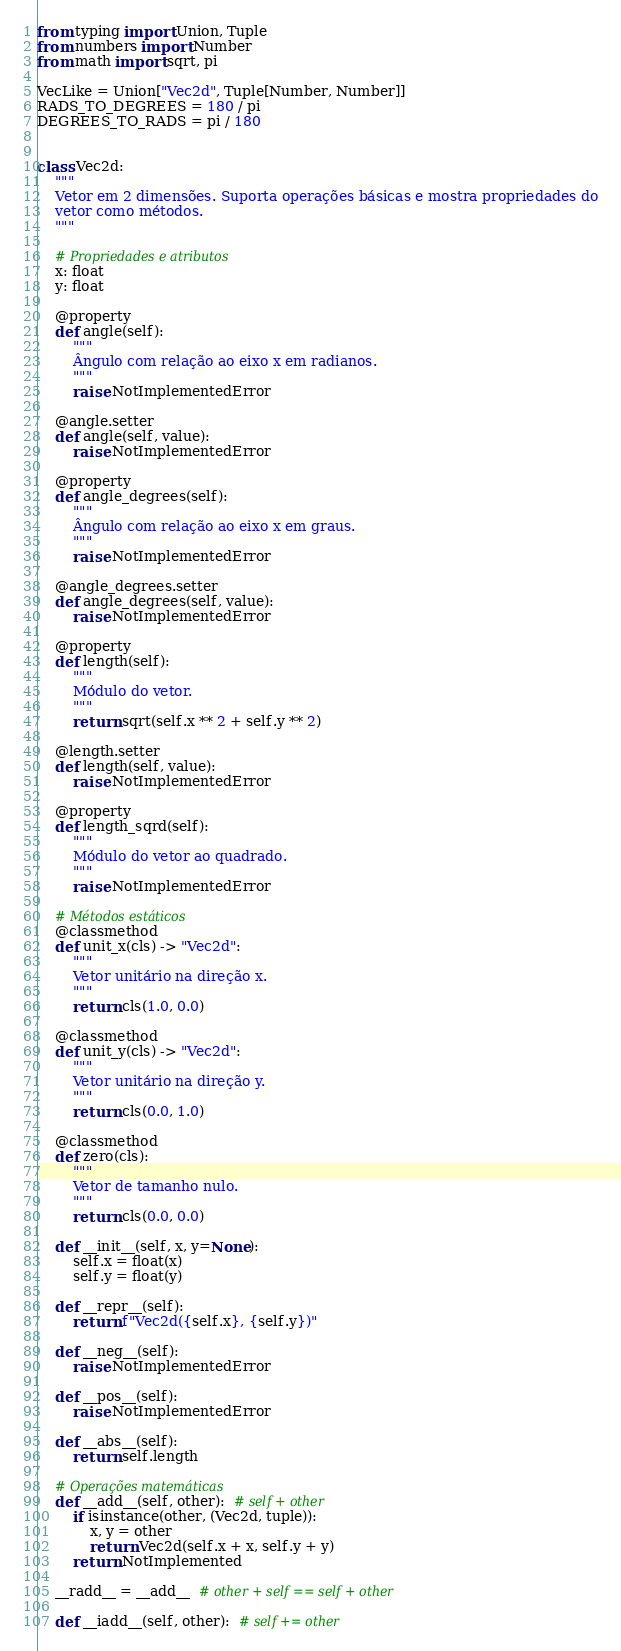<code> <loc_0><loc_0><loc_500><loc_500><_Python_>from typing import Union, Tuple
from numbers import Number
from math import sqrt, pi

VecLike = Union["Vec2d", Tuple[Number, Number]]
RADS_TO_DEGREES = 180 / pi
DEGREES_TO_RADS = pi / 180


class Vec2d:
    """
    Vetor em 2 dimensões. Suporta operações básicas e mostra propriedades do
    vetor como métodos.
    """

    # Propriedades e atributos
    x: float
    y: float

    @property
    def angle(self):
        """
        Ângulo com relação ao eixo x em radianos.
        """
        raise NotImplementedError

    @angle.setter
    def angle(self, value):
        raise NotImplementedError

    @property
    def angle_degrees(self):
        """
        Ângulo com relação ao eixo x em graus.
        """
        raise NotImplementedError

    @angle_degrees.setter
    def angle_degrees(self, value):
        raise NotImplementedError

    @property
    def length(self):
        """
        Módulo do vetor.
        """
        return sqrt(self.x ** 2 + self.y ** 2)

    @length.setter
    def length(self, value):
        raise NotImplementedError

    @property
    def length_sqrd(self):
        """
        Módulo do vetor ao quadrado.
        """
        raise NotImplementedError

    # Métodos estáticos
    @classmethod
    def unit_x(cls) -> "Vec2d":
        """
        Vetor unitário na direção x.
        """
        return cls(1.0, 0.0)

    @classmethod
    def unit_y(cls) -> "Vec2d":
        """
        Vetor unitário na direção y.
        """
        return cls(0.0, 1.0)

    @classmethod
    def zero(cls):
        """
        Vetor de tamanho nulo.
        """
        return cls(0.0, 0.0)

    def __init__(self, x, y=None):
        self.x = float(x)
        self.y = float(y)

    def __repr__(self):
        return f"Vec2d({self.x}, {self.y})"

    def __neg__(self):
        raise NotImplementedError

    def __pos__(self):
        raise NotImplementedError

    def __abs__(self):
        return self.length

    # Operações matemáticas
    def __add__(self, other):  # self + other
        if isinstance(other, (Vec2d, tuple)):
            x, y = other
            return Vec2d(self.x + x, self.y + y)
        return NotImplemented

    __radd__ = __add__  # other + self == self + other

    def __iadd__(self, other):  # self += other</code> 